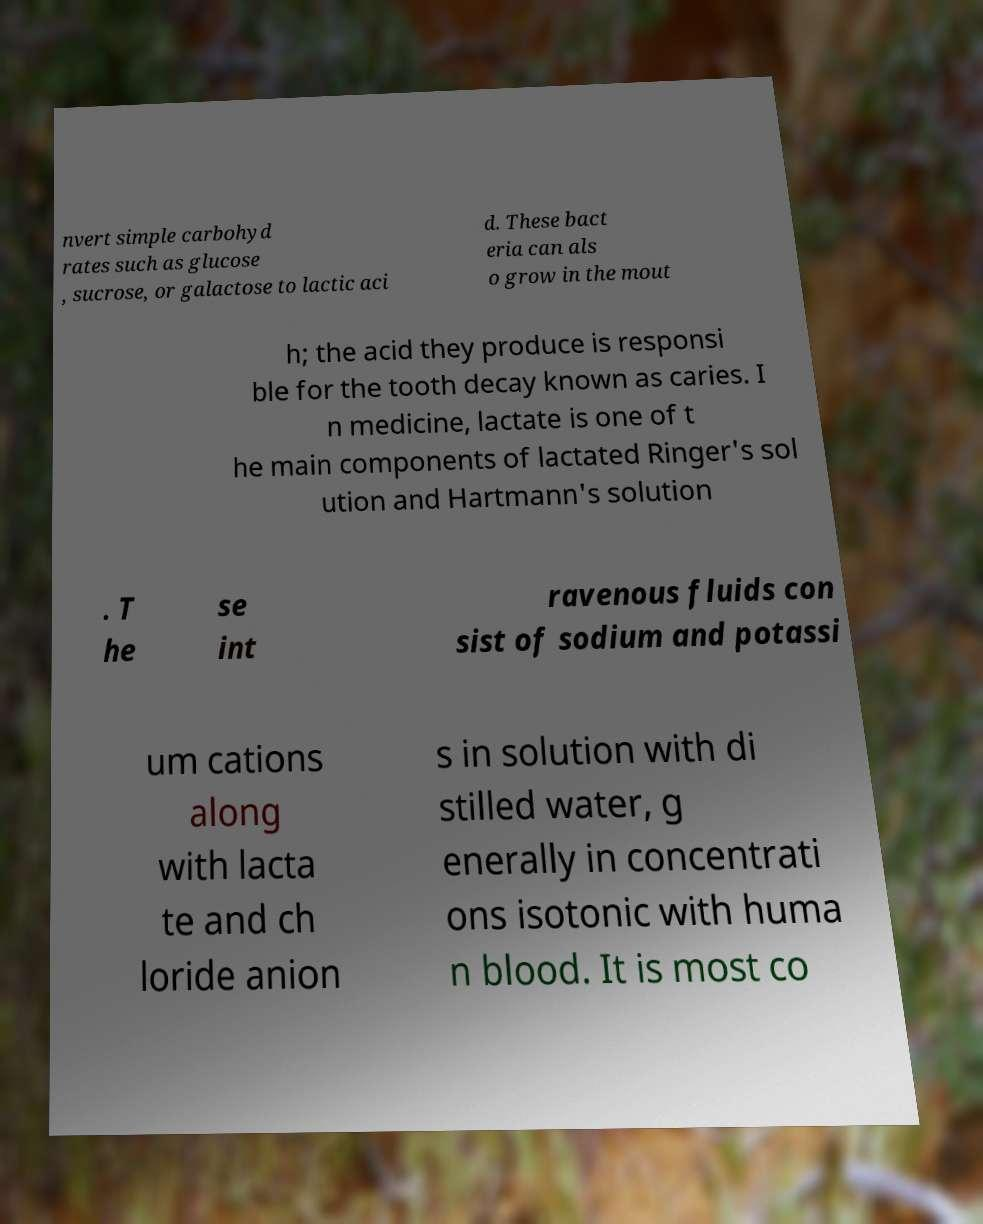I need the written content from this picture converted into text. Can you do that? nvert simple carbohyd rates such as glucose , sucrose, or galactose to lactic aci d. These bact eria can als o grow in the mout h; the acid they produce is responsi ble for the tooth decay known as caries. I n medicine, lactate is one of t he main components of lactated Ringer's sol ution and Hartmann's solution . T he se int ravenous fluids con sist of sodium and potassi um cations along with lacta te and ch loride anion s in solution with di stilled water, g enerally in concentrati ons isotonic with huma n blood. It is most co 